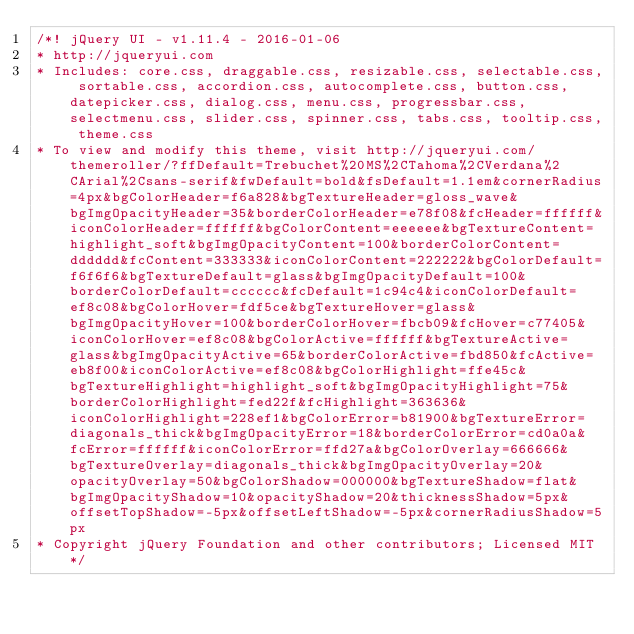Convert code to text. <code><loc_0><loc_0><loc_500><loc_500><_CSS_>/*! jQuery UI - v1.11.4 - 2016-01-06
* http://jqueryui.com
* Includes: core.css, draggable.css, resizable.css, selectable.css, sortable.css, accordion.css, autocomplete.css, button.css, datepicker.css, dialog.css, menu.css, progressbar.css, selectmenu.css, slider.css, spinner.css, tabs.css, tooltip.css, theme.css
* To view and modify this theme, visit http://jqueryui.com/themeroller/?ffDefault=Trebuchet%20MS%2CTahoma%2CVerdana%2CArial%2Csans-serif&fwDefault=bold&fsDefault=1.1em&cornerRadius=4px&bgColorHeader=f6a828&bgTextureHeader=gloss_wave&bgImgOpacityHeader=35&borderColorHeader=e78f08&fcHeader=ffffff&iconColorHeader=ffffff&bgColorContent=eeeeee&bgTextureContent=highlight_soft&bgImgOpacityContent=100&borderColorContent=dddddd&fcContent=333333&iconColorContent=222222&bgColorDefault=f6f6f6&bgTextureDefault=glass&bgImgOpacityDefault=100&borderColorDefault=cccccc&fcDefault=1c94c4&iconColorDefault=ef8c08&bgColorHover=fdf5ce&bgTextureHover=glass&bgImgOpacityHover=100&borderColorHover=fbcb09&fcHover=c77405&iconColorHover=ef8c08&bgColorActive=ffffff&bgTextureActive=glass&bgImgOpacityActive=65&borderColorActive=fbd850&fcActive=eb8f00&iconColorActive=ef8c08&bgColorHighlight=ffe45c&bgTextureHighlight=highlight_soft&bgImgOpacityHighlight=75&borderColorHighlight=fed22f&fcHighlight=363636&iconColorHighlight=228ef1&bgColorError=b81900&bgTextureError=diagonals_thick&bgImgOpacityError=18&borderColorError=cd0a0a&fcError=ffffff&iconColorError=ffd27a&bgColorOverlay=666666&bgTextureOverlay=diagonals_thick&bgImgOpacityOverlay=20&opacityOverlay=50&bgColorShadow=000000&bgTextureShadow=flat&bgImgOpacityShadow=10&opacityShadow=20&thicknessShadow=5px&offsetTopShadow=-5px&offsetLeftShadow=-5px&cornerRadiusShadow=5px
* Copyright jQuery Foundation and other contributors; Licensed MIT */
</code> 